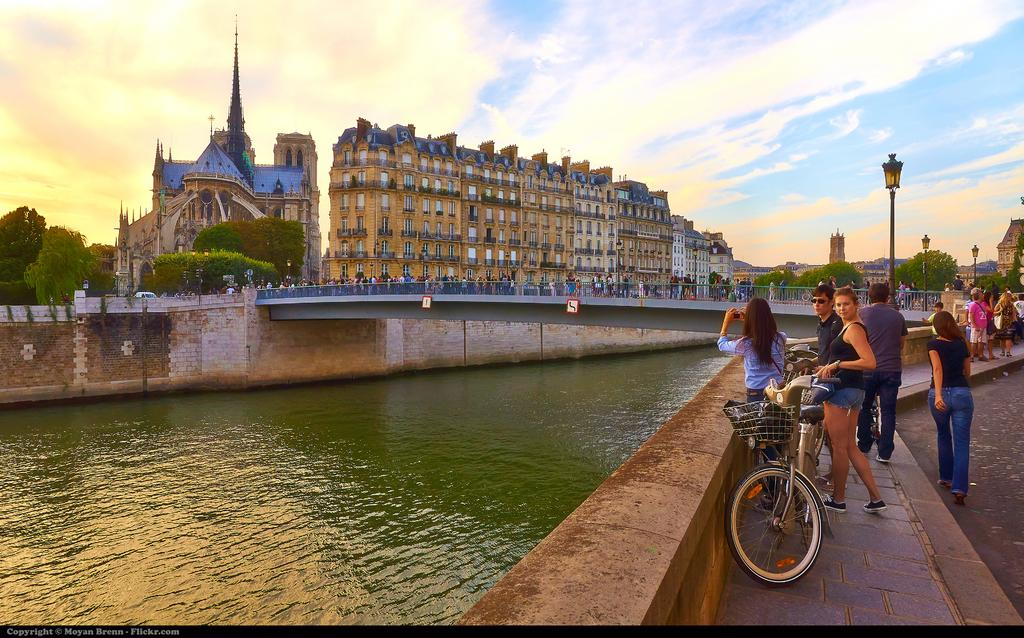How many people are in the image? There are many people in the image. What are the people wearing? The people are wearing clothes. What mode of transportation can be seen in the image? There is a bicycle in the image. What type of water is visible in the image? There is water visible in the image. What structure is present in the image that allows people to cross the water? There is a bridge in the image. What type of pole is present in the image that provides light? There is a light pole in the image. What type of building is present in the image? There is a building in the image. What feature of the building is mentioned in the facts? The building has windows. What type of vegetation is present in the image? There are trees in the image. What type of path is present in the image that people can walk on? There is a footpath in the image. How is the sky depicted in the image? The sky is cloudy in the image. What year is depicted in the image? The facts provided do not mention a specific year, so it cannot be determined from the image. What type of carriage can be seen in the image? There is no carriage present in the image. What type of judge is depicted in the image? There is no judge present in the image. 